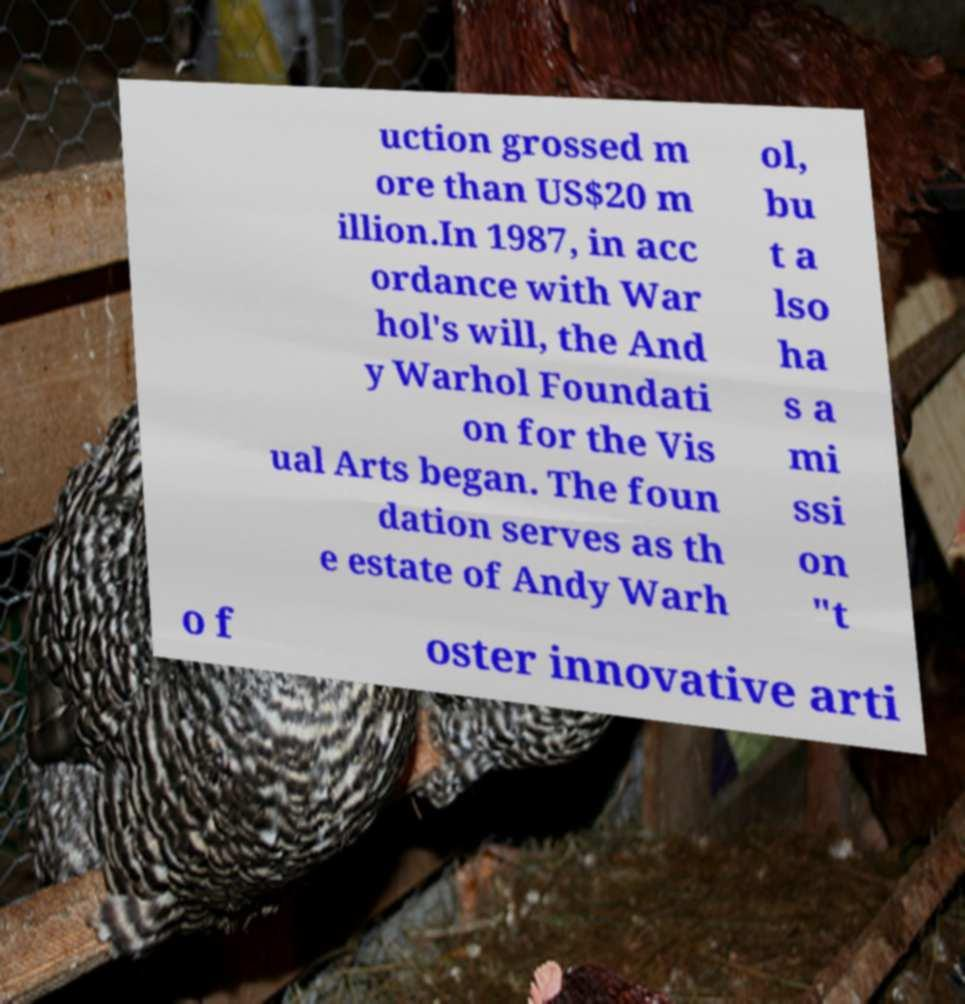Please read and relay the text visible in this image. What does it say? uction grossed m ore than US$20 m illion.In 1987, in acc ordance with War hol's will, the And y Warhol Foundati on for the Vis ual Arts began. The foun dation serves as th e estate of Andy Warh ol, bu t a lso ha s a mi ssi on "t o f oster innovative arti 